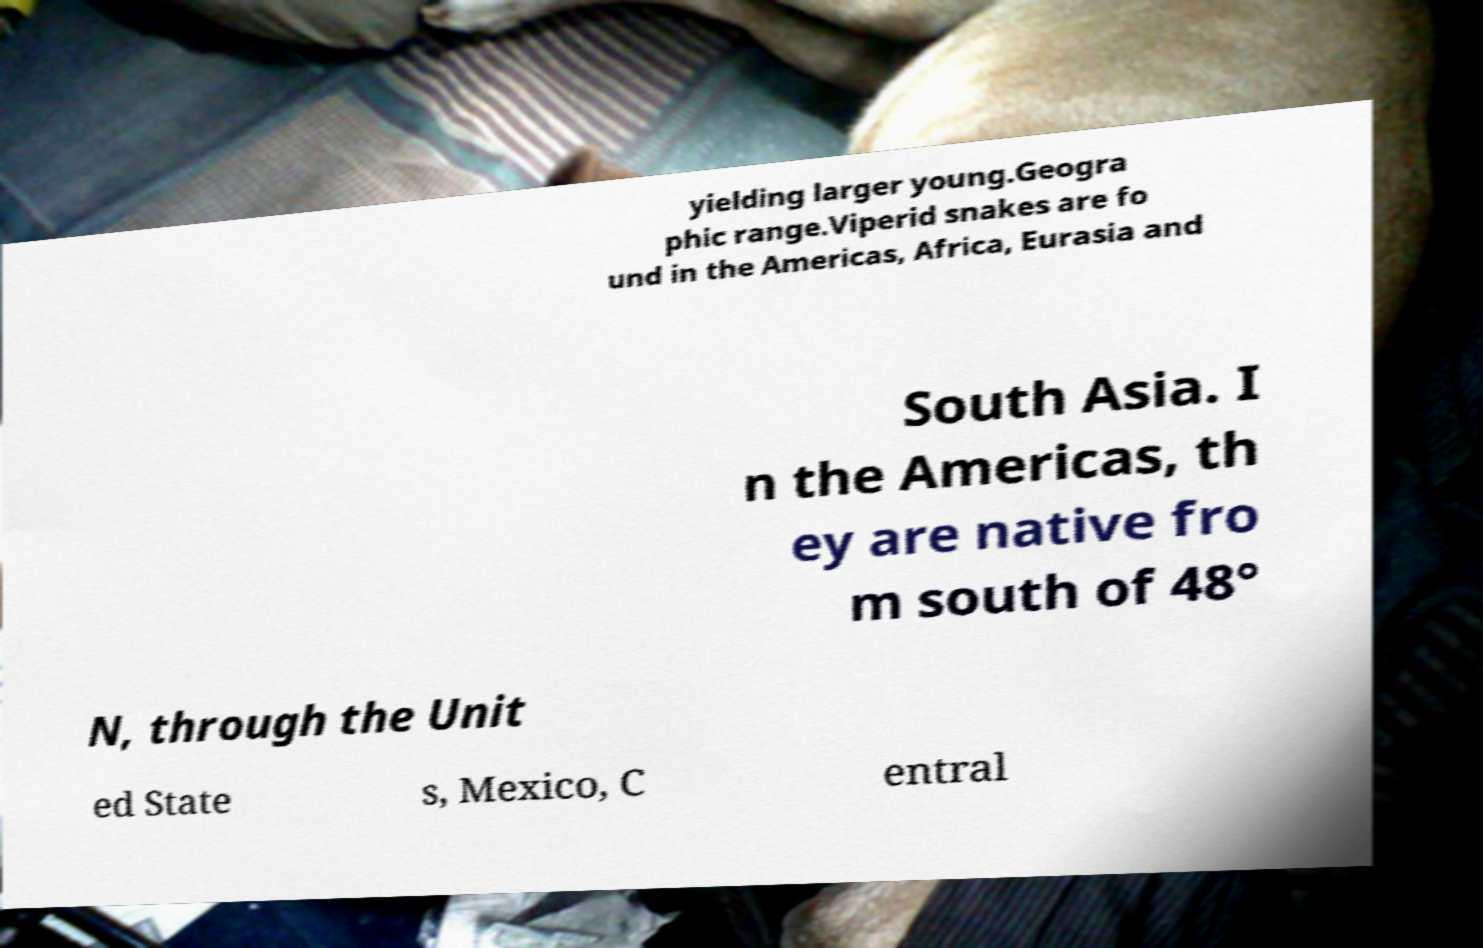Can you read and provide the text displayed in the image?This photo seems to have some interesting text. Can you extract and type it out for me? yielding larger young.Geogra phic range.Viperid snakes are fo und in the Americas, Africa, Eurasia and South Asia. I n the Americas, th ey are native fro m south of 48° N, through the Unit ed State s, Mexico, C entral 